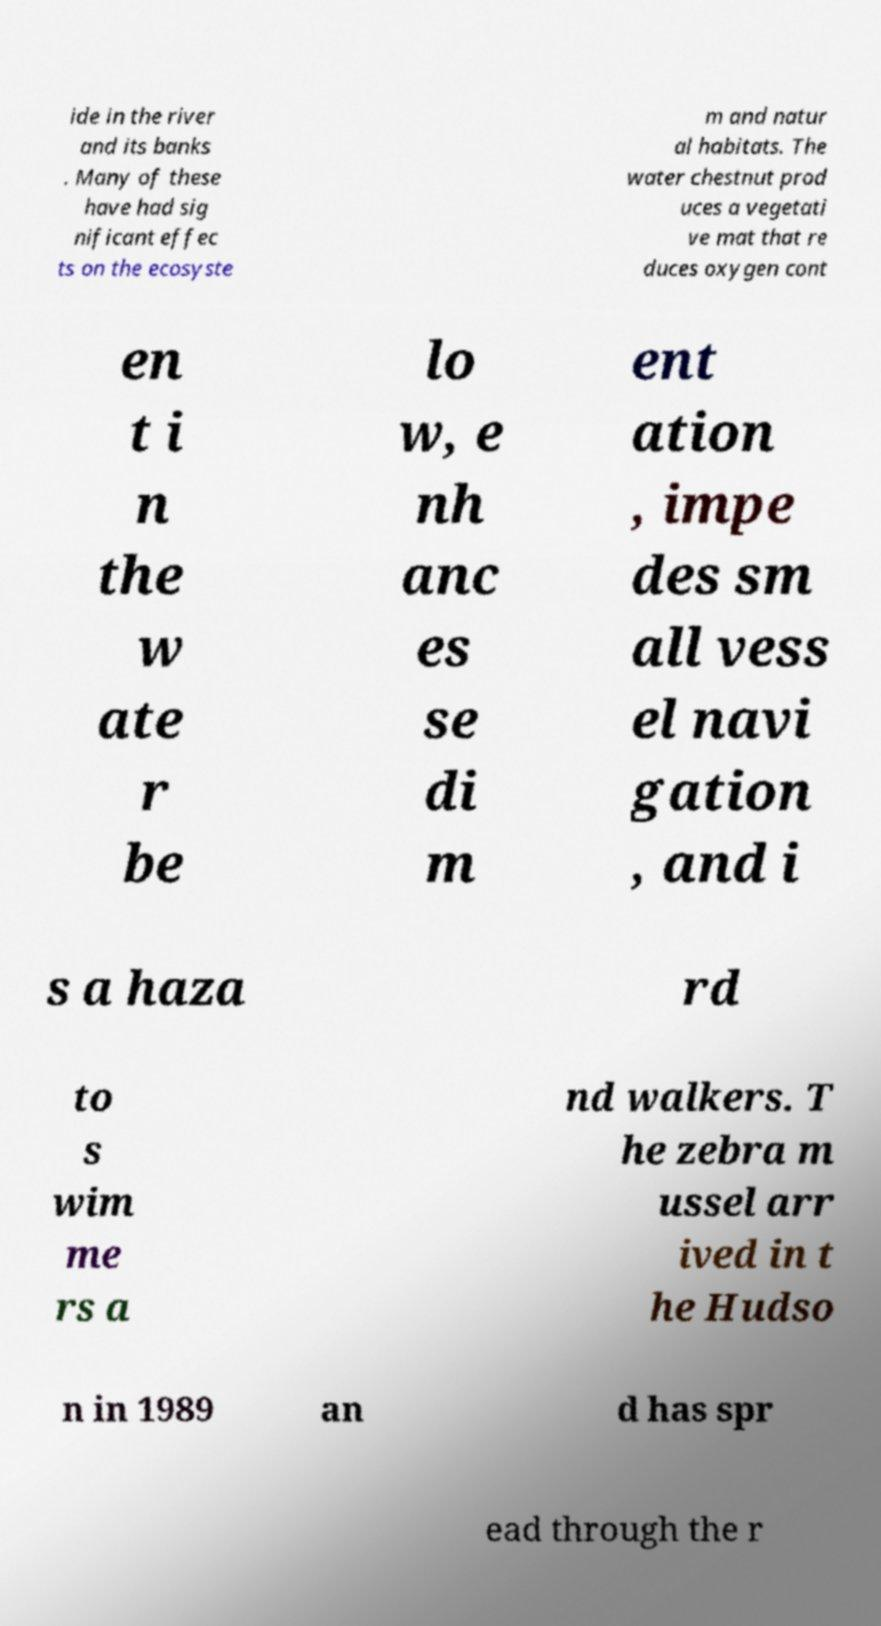Please read and relay the text visible in this image. What does it say? ide in the river and its banks . Many of these have had sig nificant effec ts on the ecosyste m and natur al habitats. The water chestnut prod uces a vegetati ve mat that re duces oxygen cont en t i n the w ate r be lo w, e nh anc es se di m ent ation , impe des sm all vess el navi gation , and i s a haza rd to s wim me rs a nd walkers. T he zebra m ussel arr ived in t he Hudso n in 1989 an d has spr ead through the r 